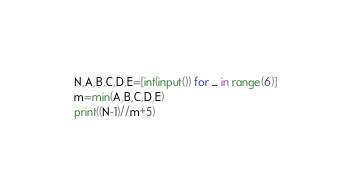Convert code to text. <code><loc_0><loc_0><loc_500><loc_500><_Python_>N,A,B,C,D,E=[int(input()) for _ in range(6)]
m=min(A,B,C,D,E)
print((N-1)//m+5)</code> 